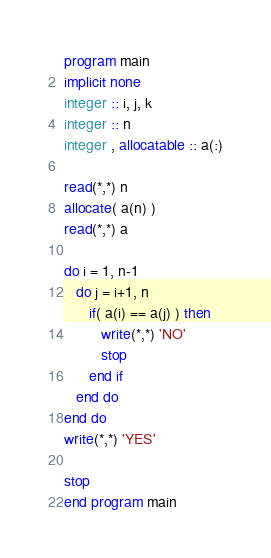Convert code to text. <code><loc_0><loc_0><loc_500><loc_500><_FORTRAN_>program main
implicit none
integer :: i, j, k
integer :: n
integer , allocatable :: a(:)

read(*,*) n
allocate( a(n) )
read(*,*) a

do i = 1, n-1
   do j = i+1, n
      if( a(i) == a(j) ) then
         write(*,*) 'NO'
         stop
      end if
   end do
end do
write(*,*) 'YES'

stop
end program main</code> 